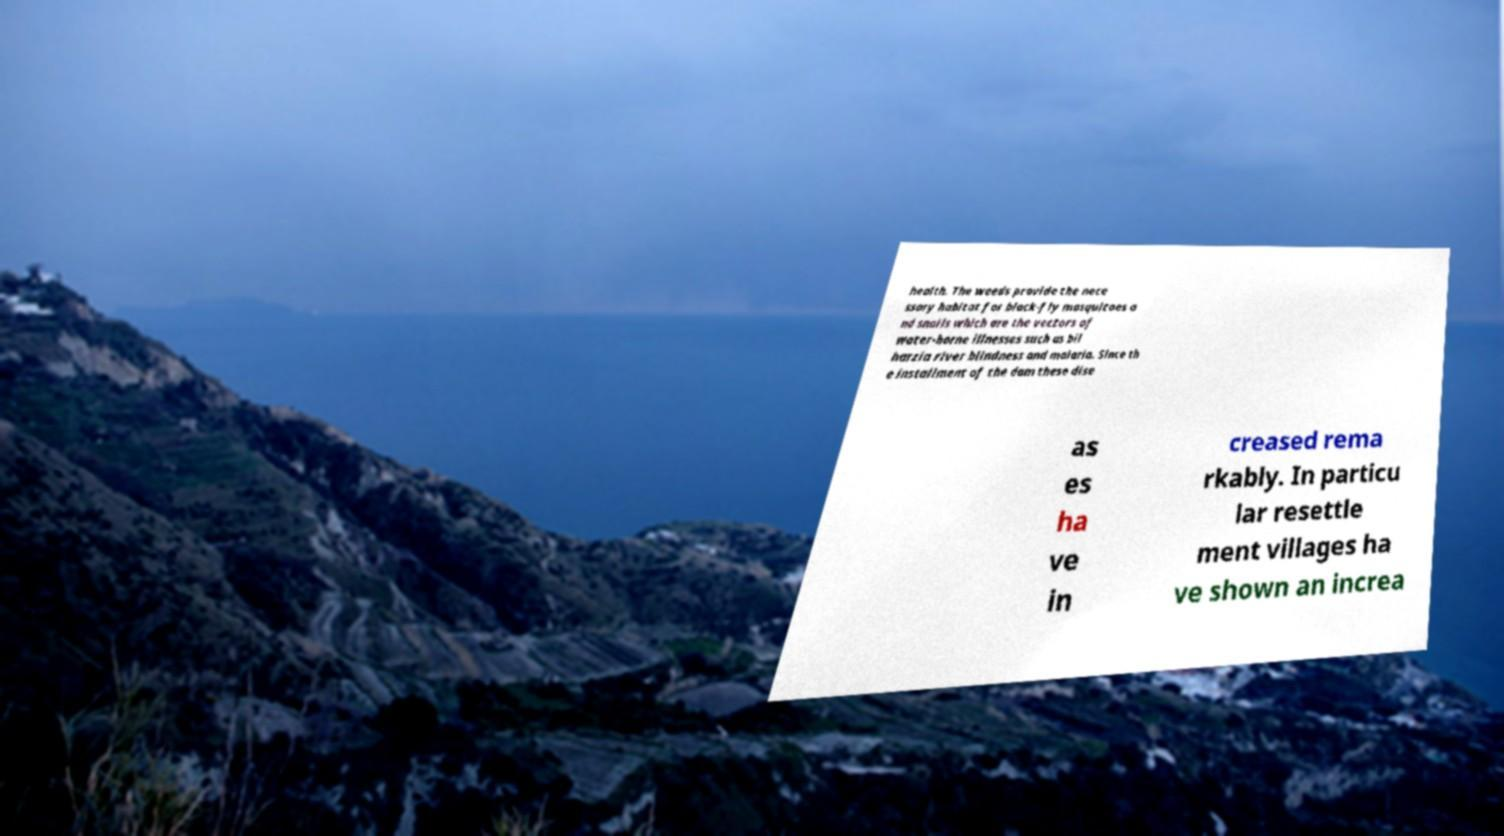Can you read and provide the text displayed in the image?This photo seems to have some interesting text. Can you extract and type it out for me? health. The weeds provide the nece ssary habitat for black-fly mosquitoes a nd snails which are the vectors of water-borne illnesses such as bil harzia river blindness and malaria. Since th e installment of the dam these dise as es ha ve in creased rema rkably. In particu lar resettle ment villages ha ve shown an increa 